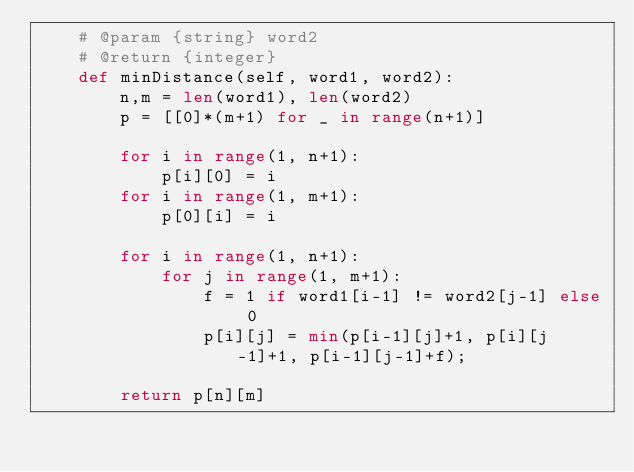Convert code to text. <code><loc_0><loc_0><loc_500><loc_500><_Python_>    # @param {string} word2
    # @return {integer}
    def minDistance(self, word1, word2):
        n,m = len(word1), len(word2)
        p = [[0]*(m+1) for _ in range(n+1)]
        
        for i in range(1, n+1):
            p[i][0] = i
        for i in range(1, m+1):
            p[0][i] = i
        
        for i in range(1, n+1):
            for j in range(1, m+1):
                f = 1 if word1[i-1] != word2[j-1] else 0
                p[i][j] = min(p[i-1][j]+1, p[i][j-1]+1, p[i-1][j-1]+f);
        
        return p[n][m]</code> 